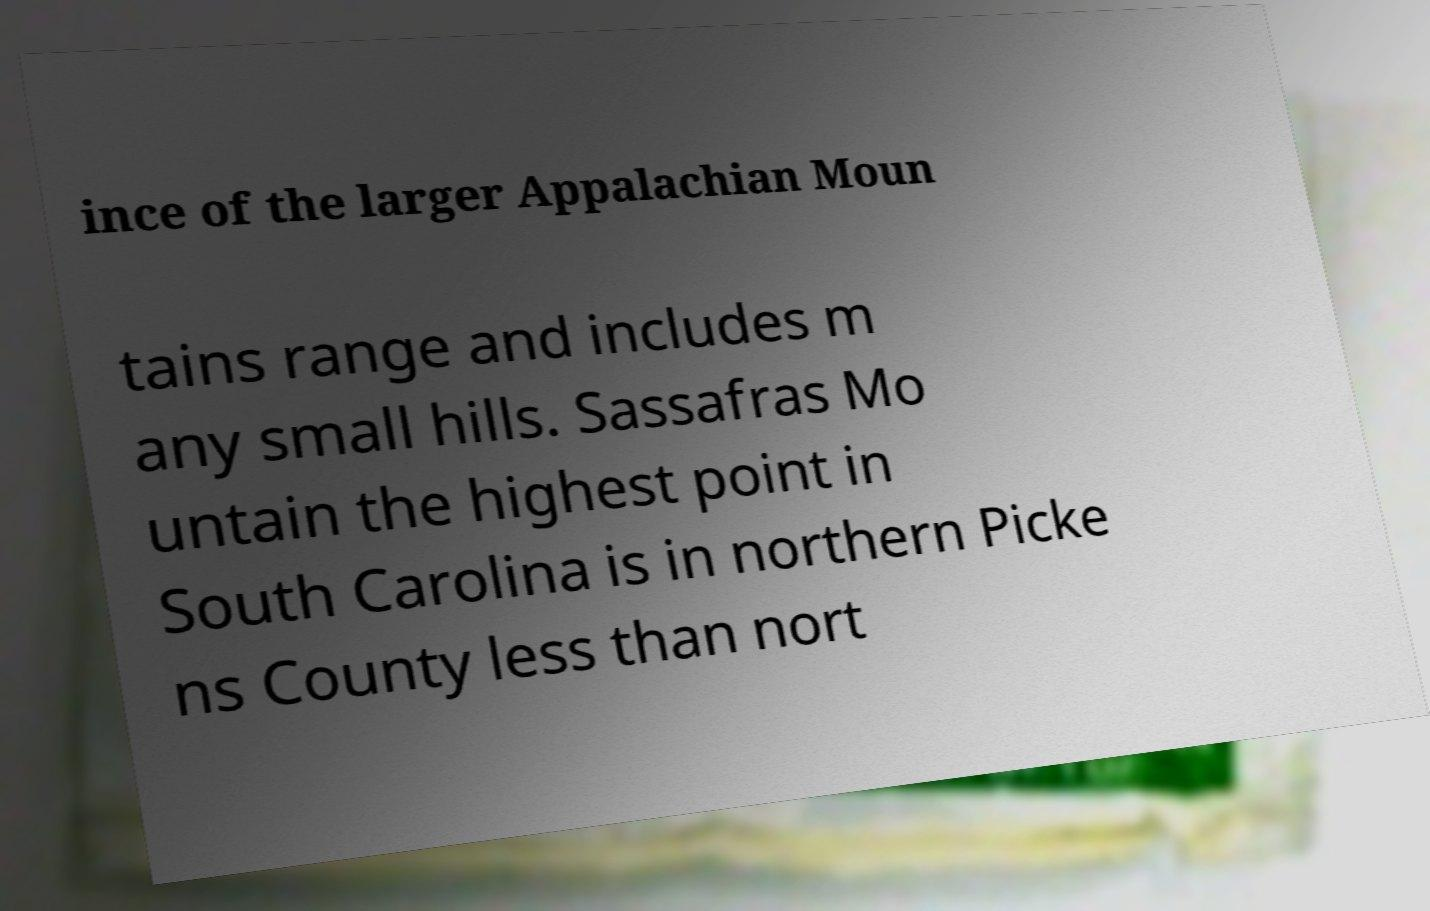For documentation purposes, I need the text within this image transcribed. Could you provide that? ince of the larger Appalachian Moun tains range and includes m any small hills. Sassafras Mo untain the highest point in South Carolina is in northern Picke ns County less than nort 